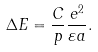Convert formula to latex. <formula><loc_0><loc_0><loc_500><loc_500>\Delta E = \frac { C } { p } \frac { e ^ { 2 } } { \varepsilon a } .</formula> 